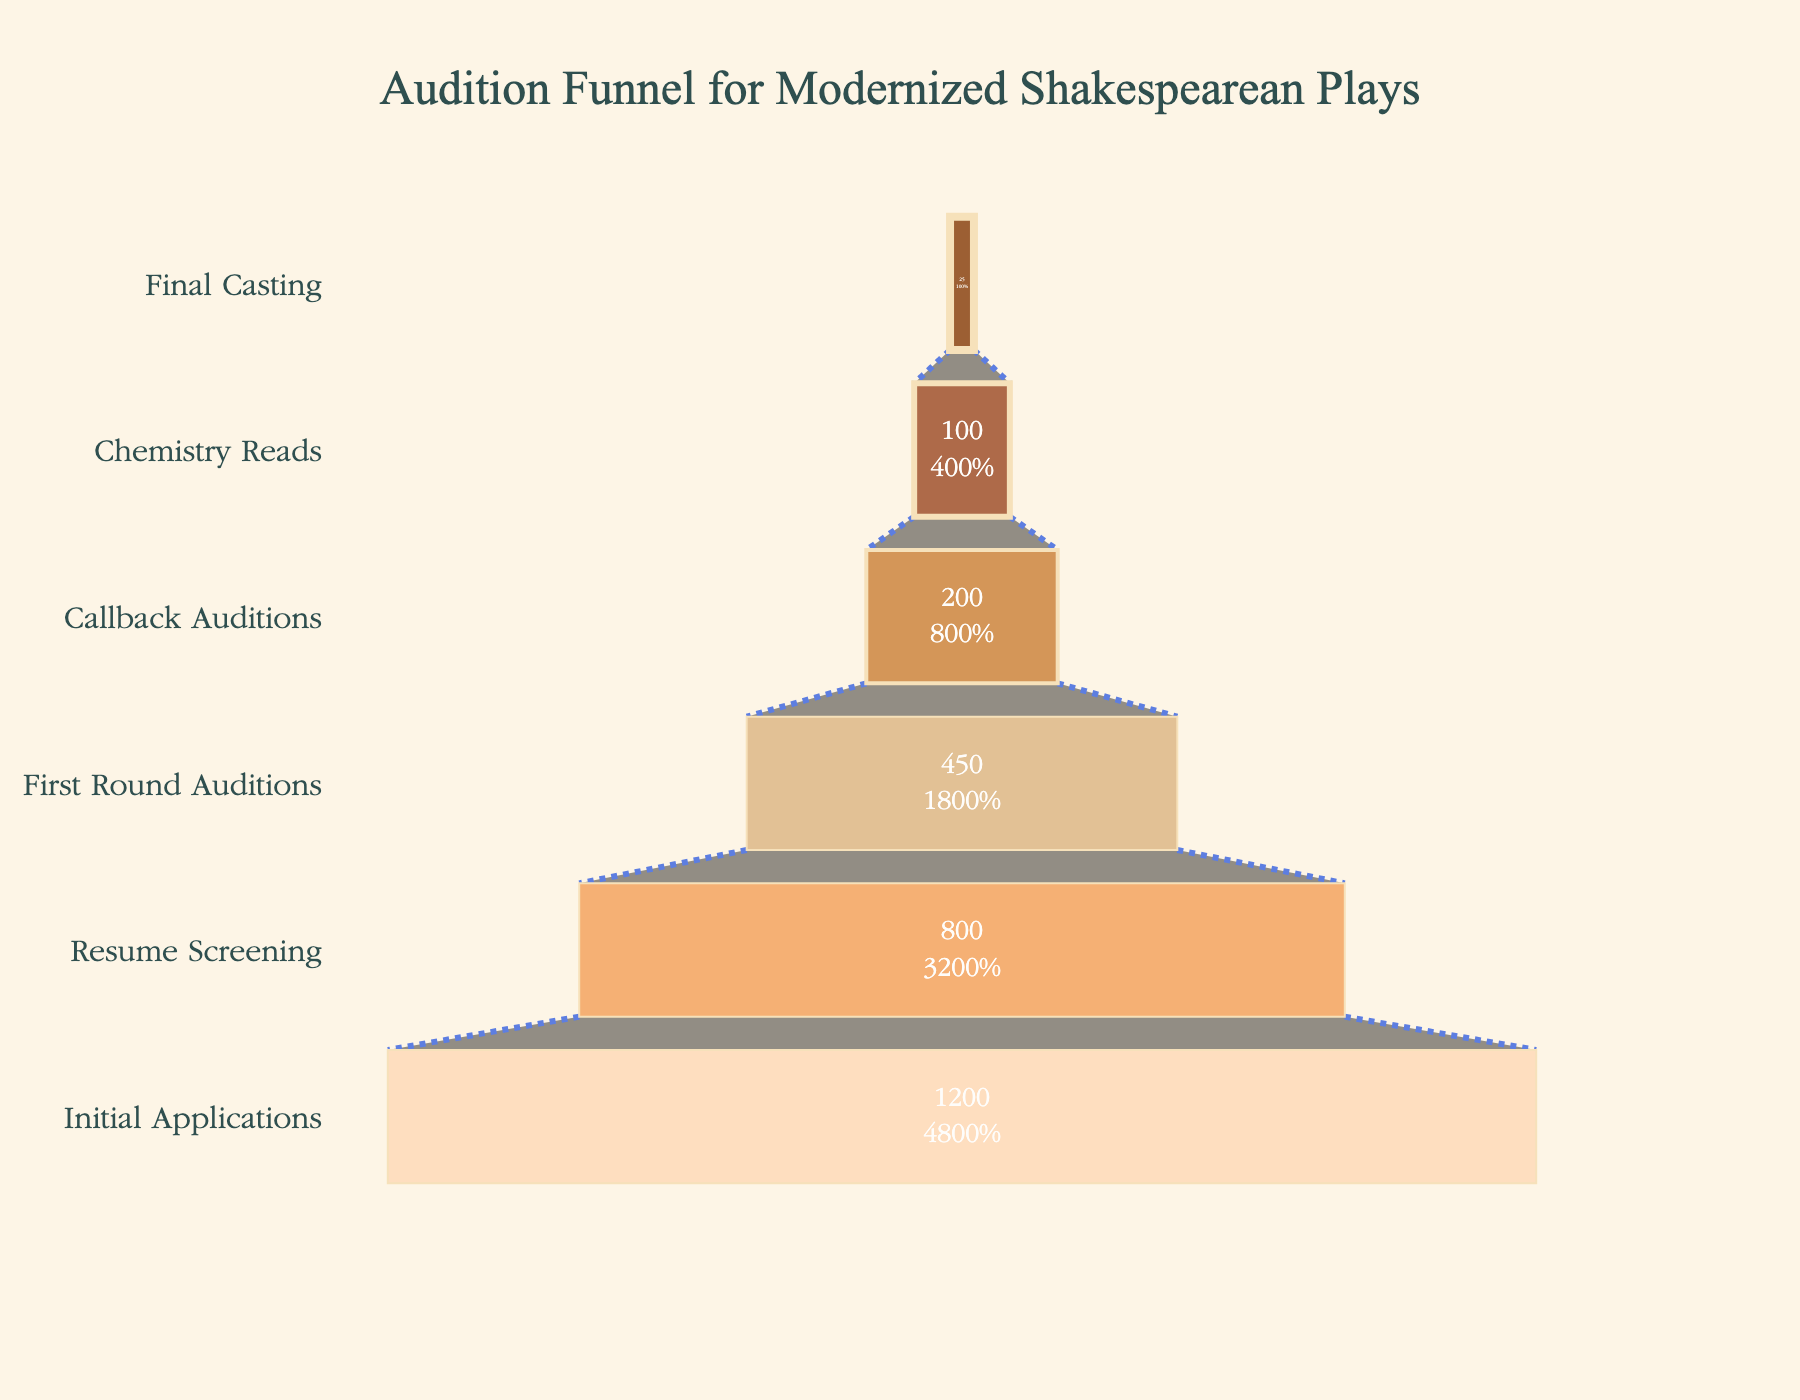How many stages are shown in the funnel? Count the number of distinct stages listed in the figure. There are six stages: Initial Applications, Resume Screening, First Round Auditions, Callback Auditions, Chemistry Reads, and Final Casting.
Answer: Six What is the title of the funnel chart? Look at the text at the top of the figure to find the title. The title is "Audition Funnel for Modernized Shakespearean Plays."
Answer: Audition Funnel for Modernized Shakespearean Plays What is the number of candidates left after the Resume Screening? Check the value next to the "Resume Screening" stage in the funnel chart. The number of candidates left is 800.
Answer: 800 How many candidates make it from the Initial Applications to the Final Casting? Subtract the number of candidates in the "Final Casting" stage from the "Initial Applications" stage. The initial number is 1200, and the final number is 25.
Answer: 25 What percentage of candidates make it to the Final Casting? Divide the number of candidates in the Final Casting (25) by the total number of Initial Applications (1200) and multiply by 100: (25/1200) * 100 = 2.08%.
Answer: 2.08% Which stage sees the largest drop in the number of candidates? Observe the differences between consecutive stages, the largest drop is between Initial Applications (1200) and Resume Screening (800), a drop of 400 candidates.
Answer: Initial Applications to Resume Screening How many total candidates are there across all stages? Sum the number of candidates across all stages: 1200 + 800 + 450 + 200 + 100 + 25. The total is 2775.
Answer: 2775 In which stage do half of the initial candidates get filtered out? Look for a stage where the remaining candidates are approximately half of the initial candidates. Around half of 1200 is 600, which is between Resume Screening (800) and First Round Auditions (450).
Answer: Resume Screening What is the retention rate from Callback Auditions to Chemistry Reads? Divide the number of candidates in Chemistry Reads (100) by the number in Callback Auditions (200) and multiply by 100: (100/200) * 100 = 50%.
Answer: 50% From the Initial Applications to the Callback Auditions, what percentage of candidates are filtered out? Subtract the number of candidates in Callback Auditions (200) from Initial Applications (1200), then divide by 1200 and multiply by 100: (1200-200)/1200 * 100 = 83.33%.
Answer: 83.33% 